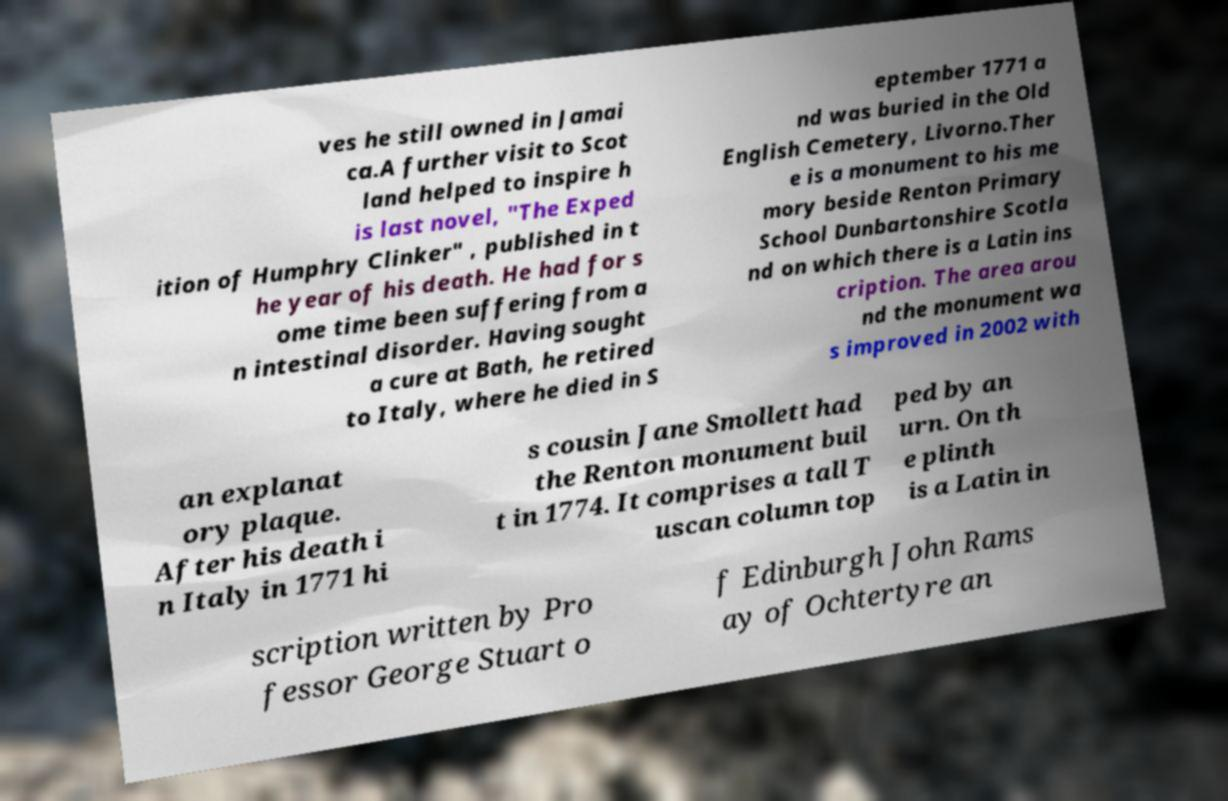Could you extract and type out the text from this image? ves he still owned in Jamai ca.A further visit to Scot land helped to inspire h is last novel, "The Exped ition of Humphry Clinker" , published in t he year of his death. He had for s ome time been suffering from a n intestinal disorder. Having sought a cure at Bath, he retired to Italy, where he died in S eptember 1771 a nd was buried in the Old English Cemetery, Livorno.Ther e is a monument to his me mory beside Renton Primary School Dunbartonshire Scotla nd on which there is a Latin ins cription. The area arou nd the monument wa s improved in 2002 with an explanat ory plaque. After his death i n Italy in 1771 hi s cousin Jane Smollett had the Renton monument buil t in 1774. It comprises a tall T uscan column top ped by an urn. On th e plinth is a Latin in scription written by Pro fessor George Stuart o f Edinburgh John Rams ay of Ochtertyre an 